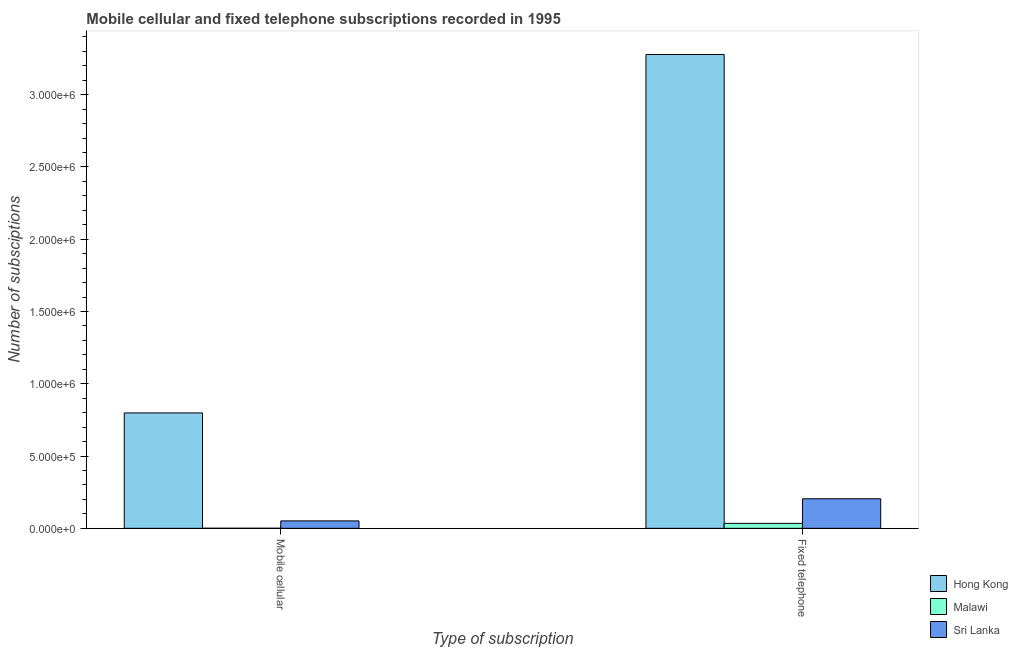How many different coloured bars are there?
Your answer should be compact. 3. How many groups of bars are there?
Offer a very short reply. 2. Are the number of bars per tick equal to the number of legend labels?
Offer a very short reply. Yes. How many bars are there on the 1st tick from the right?
Offer a very short reply. 3. What is the label of the 2nd group of bars from the left?
Provide a short and direct response. Fixed telephone. What is the number of fixed telephone subscriptions in Sri Lanka?
Make the answer very short. 2.04e+05. Across all countries, what is the maximum number of fixed telephone subscriptions?
Your response must be concise. 3.28e+06. Across all countries, what is the minimum number of mobile cellular subscriptions?
Your answer should be very brief. 382. In which country was the number of mobile cellular subscriptions maximum?
Provide a succinct answer. Hong Kong. In which country was the number of mobile cellular subscriptions minimum?
Offer a terse response. Malawi. What is the total number of mobile cellular subscriptions in the graph?
Offer a very short reply. 8.50e+05. What is the difference between the number of fixed telephone subscriptions in Malawi and that in Hong Kong?
Provide a succinct answer. -3.24e+06. What is the difference between the number of mobile cellular subscriptions in Malawi and the number of fixed telephone subscriptions in Sri Lanka?
Your answer should be compact. -2.04e+05. What is the average number of mobile cellular subscriptions per country?
Provide a succinct answer. 2.83e+05. What is the difference between the number of mobile cellular subscriptions and number of fixed telephone subscriptions in Hong Kong?
Provide a short and direct response. -2.48e+06. What is the ratio of the number of mobile cellular subscriptions in Sri Lanka to that in Hong Kong?
Ensure brevity in your answer.  0.06. In how many countries, is the number of fixed telephone subscriptions greater than the average number of fixed telephone subscriptions taken over all countries?
Provide a short and direct response. 1. What does the 3rd bar from the left in Fixed telephone represents?
Ensure brevity in your answer.  Sri Lanka. What does the 1st bar from the right in Mobile cellular represents?
Provide a short and direct response. Sri Lanka. How many bars are there?
Give a very brief answer. 6. Are all the bars in the graph horizontal?
Offer a very short reply. No. Are the values on the major ticks of Y-axis written in scientific E-notation?
Offer a terse response. Yes. Does the graph contain any zero values?
Ensure brevity in your answer.  No. Does the graph contain grids?
Provide a succinct answer. No. How many legend labels are there?
Offer a terse response. 3. What is the title of the graph?
Give a very brief answer. Mobile cellular and fixed telephone subscriptions recorded in 1995. Does "Virgin Islands" appear as one of the legend labels in the graph?
Provide a short and direct response. No. What is the label or title of the X-axis?
Provide a succinct answer. Type of subscription. What is the label or title of the Y-axis?
Give a very brief answer. Number of subsciptions. What is the Number of subsciptions in Hong Kong in Mobile cellular?
Your response must be concise. 7.98e+05. What is the Number of subsciptions in Malawi in Mobile cellular?
Keep it short and to the point. 382. What is the Number of subsciptions in Sri Lanka in Mobile cellular?
Make the answer very short. 5.13e+04. What is the Number of subsciptions of Hong Kong in Fixed telephone?
Make the answer very short. 3.28e+06. What is the Number of subsciptions in Malawi in Fixed telephone?
Your answer should be very brief. 3.43e+04. What is the Number of subsciptions of Sri Lanka in Fixed telephone?
Your answer should be compact. 2.04e+05. Across all Type of subscription, what is the maximum Number of subsciptions of Hong Kong?
Your response must be concise. 3.28e+06. Across all Type of subscription, what is the maximum Number of subsciptions in Malawi?
Ensure brevity in your answer.  3.43e+04. Across all Type of subscription, what is the maximum Number of subsciptions in Sri Lanka?
Give a very brief answer. 2.04e+05. Across all Type of subscription, what is the minimum Number of subsciptions in Hong Kong?
Offer a terse response. 7.98e+05. Across all Type of subscription, what is the minimum Number of subsciptions of Malawi?
Keep it short and to the point. 382. Across all Type of subscription, what is the minimum Number of subsciptions in Sri Lanka?
Make the answer very short. 5.13e+04. What is the total Number of subsciptions in Hong Kong in the graph?
Give a very brief answer. 4.08e+06. What is the total Number of subsciptions in Malawi in the graph?
Your answer should be very brief. 3.47e+04. What is the total Number of subsciptions of Sri Lanka in the graph?
Your response must be concise. 2.56e+05. What is the difference between the Number of subsciptions of Hong Kong in Mobile cellular and that in Fixed telephone?
Offer a very short reply. -2.48e+06. What is the difference between the Number of subsciptions of Malawi in Mobile cellular and that in Fixed telephone?
Provide a succinct answer. -3.40e+04. What is the difference between the Number of subsciptions of Sri Lanka in Mobile cellular and that in Fixed telephone?
Your answer should be compact. -1.53e+05. What is the difference between the Number of subsciptions of Hong Kong in Mobile cellular and the Number of subsciptions of Malawi in Fixed telephone?
Ensure brevity in your answer.  7.64e+05. What is the difference between the Number of subsciptions in Hong Kong in Mobile cellular and the Number of subsciptions in Sri Lanka in Fixed telephone?
Offer a very short reply. 5.94e+05. What is the difference between the Number of subsciptions of Malawi in Mobile cellular and the Number of subsciptions of Sri Lanka in Fixed telephone?
Your answer should be very brief. -2.04e+05. What is the average Number of subsciptions of Hong Kong per Type of subscription?
Your answer should be compact. 2.04e+06. What is the average Number of subsciptions in Malawi per Type of subscription?
Provide a succinct answer. 1.74e+04. What is the average Number of subsciptions in Sri Lanka per Type of subscription?
Make the answer very short. 1.28e+05. What is the difference between the Number of subsciptions in Hong Kong and Number of subsciptions in Malawi in Mobile cellular?
Your answer should be compact. 7.98e+05. What is the difference between the Number of subsciptions in Hong Kong and Number of subsciptions in Sri Lanka in Mobile cellular?
Your answer should be very brief. 7.47e+05. What is the difference between the Number of subsciptions of Malawi and Number of subsciptions of Sri Lanka in Mobile cellular?
Ensure brevity in your answer.  -5.09e+04. What is the difference between the Number of subsciptions of Hong Kong and Number of subsciptions of Malawi in Fixed telephone?
Your answer should be compact. 3.24e+06. What is the difference between the Number of subsciptions of Hong Kong and Number of subsciptions of Sri Lanka in Fixed telephone?
Offer a very short reply. 3.07e+06. What is the difference between the Number of subsciptions of Malawi and Number of subsciptions of Sri Lanka in Fixed telephone?
Your response must be concise. -1.70e+05. What is the ratio of the Number of subsciptions in Hong Kong in Mobile cellular to that in Fixed telephone?
Ensure brevity in your answer.  0.24. What is the ratio of the Number of subsciptions in Malawi in Mobile cellular to that in Fixed telephone?
Your response must be concise. 0.01. What is the ratio of the Number of subsciptions of Sri Lanka in Mobile cellular to that in Fixed telephone?
Your answer should be compact. 0.25. What is the difference between the highest and the second highest Number of subsciptions in Hong Kong?
Offer a very short reply. 2.48e+06. What is the difference between the highest and the second highest Number of subsciptions in Malawi?
Provide a succinct answer. 3.40e+04. What is the difference between the highest and the second highest Number of subsciptions of Sri Lanka?
Give a very brief answer. 1.53e+05. What is the difference between the highest and the lowest Number of subsciptions of Hong Kong?
Keep it short and to the point. 2.48e+06. What is the difference between the highest and the lowest Number of subsciptions of Malawi?
Ensure brevity in your answer.  3.40e+04. What is the difference between the highest and the lowest Number of subsciptions in Sri Lanka?
Provide a succinct answer. 1.53e+05. 